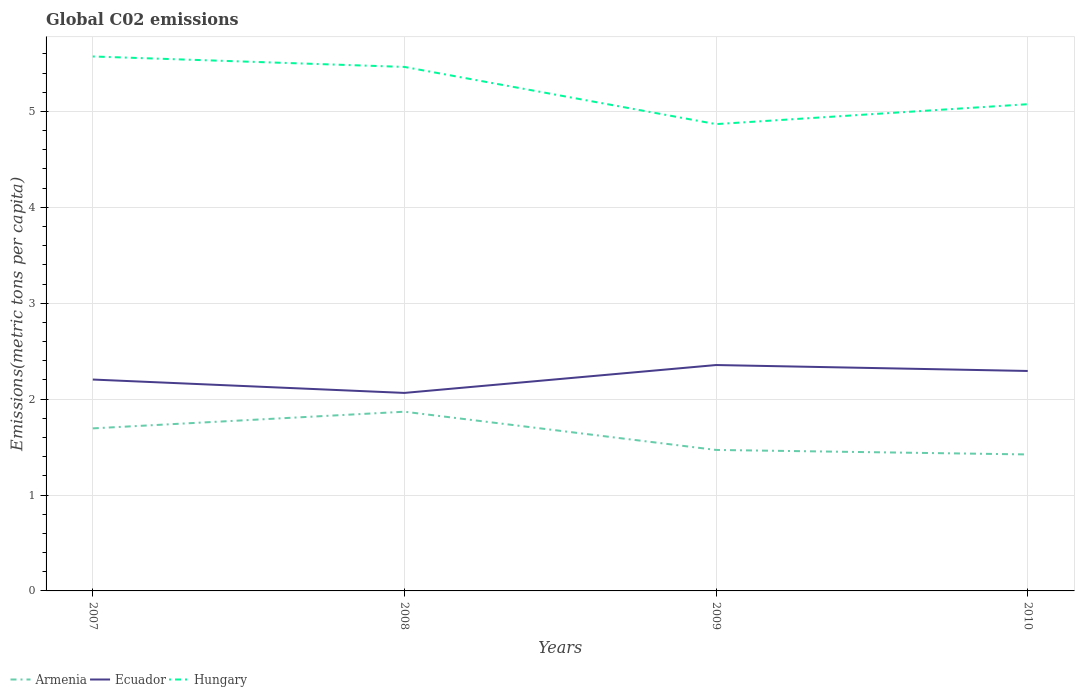Does the line corresponding to Ecuador intersect with the line corresponding to Armenia?
Offer a very short reply. No. Across all years, what is the maximum amount of CO2 emitted in in Hungary?
Give a very brief answer. 4.87. In which year was the amount of CO2 emitted in in Ecuador maximum?
Provide a succinct answer. 2008. What is the total amount of CO2 emitted in in Armenia in the graph?
Make the answer very short. 0.45. What is the difference between the highest and the second highest amount of CO2 emitted in in Hungary?
Offer a terse response. 0.71. What is the difference between the highest and the lowest amount of CO2 emitted in in Hungary?
Your answer should be compact. 2. How many lines are there?
Provide a succinct answer. 3. How many years are there in the graph?
Provide a short and direct response. 4. Does the graph contain any zero values?
Keep it short and to the point. No. Does the graph contain grids?
Keep it short and to the point. Yes. How many legend labels are there?
Give a very brief answer. 3. How are the legend labels stacked?
Make the answer very short. Horizontal. What is the title of the graph?
Offer a terse response. Global C02 emissions. What is the label or title of the X-axis?
Your response must be concise. Years. What is the label or title of the Y-axis?
Your answer should be compact. Emissions(metric tons per capita). What is the Emissions(metric tons per capita) of Armenia in 2007?
Your answer should be compact. 1.69. What is the Emissions(metric tons per capita) of Ecuador in 2007?
Provide a succinct answer. 2.2. What is the Emissions(metric tons per capita) of Hungary in 2007?
Your response must be concise. 5.57. What is the Emissions(metric tons per capita) of Armenia in 2008?
Ensure brevity in your answer.  1.87. What is the Emissions(metric tons per capita) in Ecuador in 2008?
Offer a terse response. 2.06. What is the Emissions(metric tons per capita) of Hungary in 2008?
Make the answer very short. 5.46. What is the Emissions(metric tons per capita) of Armenia in 2009?
Your response must be concise. 1.47. What is the Emissions(metric tons per capita) in Ecuador in 2009?
Make the answer very short. 2.36. What is the Emissions(metric tons per capita) of Hungary in 2009?
Provide a succinct answer. 4.87. What is the Emissions(metric tons per capita) in Armenia in 2010?
Make the answer very short. 1.42. What is the Emissions(metric tons per capita) in Ecuador in 2010?
Provide a short and direct response. 2.29. What is the Emissions(metric tons per capita) of Hungary in 2010?
Give a very brief answer. 5.07. Across all years, what is the maximum Emissions(metric tons per capita) in Armenia?
Provide a succinct answer. 1.87. Across all years, what is the maximum Emissions(metric tons per capita) in Ecuador?
Give a very brief answer. 2.36. Across all years, what is the maximum Emissions(metric tons per capita) of Hungary?
Your answer should be very brief. 5.57. Across all years, what is the minimum Emissions(metric tons per capita) of Armenia?
Offer a very short reply. 1.42. Across all years, what is the minimum Emissions(metric tons per capita) in Ecuador?
Ensure brevity in your answer.  2.06. Across all years, what is the minimum Emissions(metric tons per capita) of Hungary?
Your answer should be very brief. 4.87. What is the total Emissions(metric tons per capita) in Armenia in the graph?
Your response must be concise. 6.46. What is the total Emissions(metric tons per capita) of Ecuador in the graph?
Your answer should be compact. 8.92. What is the total Emissions(metric tons per capita) in Hungary in the graph?
Offer a very short reply. 20.98. What is the difference between the Emissions(metric tons per capita) in Armenia in 2007 and that in 2008?
Offer a terse response. -0.17. What is the difference between the Emissions(metric tons per capita) in Ecuador in 2007 and that in 2008?
Your answer should be compact. 0.14. What is the difference between the Emissions(metric tons per capita) of Hungary in 2007 and that in 2008?
Offer a very short reply. 0.11. What is the difference between the Emissions(metric tons per capita) in Armenia in 2007 and that in 2009?
Keep it short and to the point. 0.22. What is the difference between the Emissions(metric tons per capita) of Ecuador in 2007 and that in 2009?
Offer a very short reply. -0.15. What is the difference between the Emissions(metric tons per capita) of Hungary in 2007 and that in 2009?
Your answer should be compact. 0.71. What is the difference between the Emissions(metric tons per capita) in Armenia in 2007 and that in 2010?
Your answer should be compact. 0.27. What is the difference between the Emissions(metric tons per capita) in Ecuador in 2007 and that in 2010?
Keep it short and to the point. -0.09. What is the difference between the Emissions(metric tons per capita) of Hungary in 2007 and that in 2010?
Provide a succinct answer. 0.5. What is the difference between the Emissions(metric tons per capita) of Armenia in 2008 and that in 2009?
Offer a terse response. 0.4. What is the difference between the Emissions(metric tons per capita) in Ecuador in 2008 and that in 2009?
Ensure brevity in your answer.  -0.29. What is the difference between the Emissions(metric tons per capita) of Hungary in 2008 and that in 2009?
Keep it short and to the point. 0.6. What is the difference between the Emissions(metric tons per capita) of Armenia in 2008 and that in 2010?
Ensure brevity in your answer.  0.45. What is the difference between the Emissions(metric tons per capita) of Ecuador in 2008 and that in 2010?
Your response must be concise. -0.23. What is the difference between the Emissions(metric tons per capita) of Hungary in 2008 and that in 2010?
Keep it short and to the point. 0.39. What is the difference between the Emissions(metric tons per capita) in Armenia in 2009 and that in 2010?
Offer a very short reply. 0.05. What is the difference between the Emissions(metric tons per capita) in Ecuador in 2009 and that in 2010?
Provide a short and direct response. 0.06. What is the difference between the Emissions(metric tons per capita) in Hungary in 2009 and that in 2010?
Your response must be concise. -0.21. What is the difference between the Emissions(metric tons per capita) in Armenia in 2007 and the Emissions(metric tons per capita) in Ecuador in 2008?
Your answer should be very brief. -0.37. What is the difference between the Emissions(metric tons per capita) in Armenia in 2007 and the Emissions(metric tons per capita) in Hungary in 2008?
Your answer should be compact. -3.77. What is the difference between the Emissions(metric tons per capita) of Ecuador in 2007 and the Emissions(metric tons per capita) of Hungary in 2008?
Your response must be concise. -3.26. What is the difference between the Emissions(metric tons per capita) in Armenia in 2007 and the Emissions(metric tons per capita) in Ecuador in 2009?
Your answer should be compact. -0.66. What is the difference between the Emissions(metric tons per capita) of Armenia in 2007 and the Emissions(metric tons per capita) of Hungary in 2009?
Offer a terse response. -3.17. What is the difference between the Emissions(metric tons per capita) of Ecuador in 2007 and the Emissions(metric tons per capita) of Hungary in 2009?
Ensure brevity in your answer.  -2.66. What is the difference between the Emissions(metric tons per capita) of Armenia in 2007 and the Emissions(metric tons per capita) of Ecuador in 2010?
Make the answer very short. -0.6. What is the difference between the Emissions(metric tons per capita) in Armenia in 2007 and the Emissions(metric tons per capita) in Hungary in 2010?
Ensure brevity in your answer.  -3.38. What is the difference between the Emissions(metric tons per capita) in Ecuador in 2007 and the Emissions(metric tons per capita) in Hungary in 2010?
Make the answer very short. -2.87. What is the difference between the Emissions(metric tons per capita) of Armenia in 2008 and the Emissions(metric tons per capita) of Ecuador in 2009?
Give a very brief answer. -0.49. What is the difference between the Emissions(metric tons per capita) in Armenia in 2008 and the Emissions(metric tons per capita) in Hungary in 2009?
Your response must be concise. -3. What is the difference between the Emissions(metric tons per capita) of Ecuador in 2008 and the Emissions(metric tons per capita) of Hungary in 2009?
Make the answer very short. -2.8. What is the difference between the Emissions(metric tons per capita) in Armenia in 2008 and the Emissions(metric tons per capita) in Ecuador in 2010?
Your answer should be very brief. -0.42. What is the difference between the Emissions(metric tons per capita) in Armenia in 2008 and the Emissions(metric tons per capita) in Hungary in 2010?
Keep it short and to the point. -3.21. What is the difference between the Emissions(metric tons per capita) of Ecuador in 2008 and the Emissions(metric tons per capita) of Hungary in 2010?
Ensure brevity in your answer.  -3.01. What is the difference between the Emissions(metric tons per capita) in Armenia in 2009 and the Emissions(metric tons per capita) in Ecuador in 2010?
Give a very brief answer. -0.82. What is the difference between the Emissions(metric tons per capita) of Armenia in 2009 and the Emissions(metric tons per capita) of Hungary in 2010?
Give a very brief answer. -3.6. What is the difference between the Emissions(metric tons per capita) in Ecuador in 2009 and the Emissions(metric tons per capita) in Hungary in 2010?
Provide a succinct answer. -2.72. What is the average Emissions(metric tons per capita) in Armenia per year?
Your response must be concise. 1.61. What is the average Emissions(metric tons per capita) in Ecuador per year?
Make the answer very short. 2.23. What is the average Emissions(metric tons per capita) of Hungary per year?
Offer a terse response. 5.24. In the year 2007, what is the difference between the Emissions(metric tons per capita) of Armenia and Emissions(metric tons per capita) of Ecuador?
Give a very brief answer. -0.51. In the year 2007, what is the difference between the Emissions(metric tons per capita) of Armenia and Emissions(metric tons per capita) of Hungary?
Provide a succinct answer. -3.88. In the year 2007, what is the difference between the Emissions(metric tons per capita) in Ecuador and Emissions(metric tons per capita) in Hungary?
Give a very brief answer. -3.37. In the year 2008, what is the difference between the Emissions(metric tons per capita) of Armenia and Emissions(metric tons per capita) of Ecuador?
Your answer should be very brief. -0.2. In the year 2008, what is the difference between the Emissions(metric tons per capita) of Armenia and Emissions(metric tons per capita) of Hungary?
Your answer should be very brief. -3.59. In the year 2008, what is the difference between the Emissions(metric tons per capita) in Ecuador and Emissions(metric tons per capita) in Hungary?
Ensure brevity in your answer.  -3.4. In the year 2009, what is the difference between the Emissions(metric tons per capita) in Armenia and Emissions(metric tons per capita) in Ecuador?
Your answer should be very brief. -0.89. In the year 2009, what is the difference between the Emissions(metric tons per capita) in Armenia and Emissions(metric tons per capita) in Hungary?
Your answer should be compact. -3.4. In the year 2009, what is the difference between the Emissions(metric tons per capita) of Ecuador and Emissions(metric tons per capita) of Hungary?
Your answer should be compact. -2.51. In the year 2010, what is the difference between the Emissions(metric tons per capita) in Armenia and Emissions(metric tons per capita) in Ecuador?
Offer a very short reply. -0.87. In the year 2010, what is the difference between the Emissions(metric tons per capita) of Armenia and Emissions(metric tons per capita) of Hungary?
Offer a terse response. -3.65. In the year 2010, what is the difference between the Emissions(metric tons per capita) in Ecuador and Emissions(metric tons per capita) in Hungary?
Offer a terse response. -2.78. What is the ratio of the Emissions(metric tons per capita) of Armenia in 2007 to that in 2008?
Provide a succinct answer. 0.91. What is the ratio of the Emissions(metric tons per capita) of Ecuador in 2007 to that in 2008?
Make the answer very short. 1.07. What is the ratio of the Emissions(metric tons per capita) of Hungary in 2007 to that in 2008?
Give a very brief answer. 1.02. What is the ratio of the Emissions(metric tons per capita) of Armenia in 2007 to that in 2009?
Provide a succinct answer. 1.15. What is the ratio of the Emissions(metric tons per capita) in Ecuador in 2007 to that in 2009?
Provide a succinct answer. 0.94. What is the ratio of the Emissions(metric tons per capita) of Hungary in 2007 to that in 2009?
Offer a very short reply. 1.14. What is the ratio of the Emissions(metric tons per capita) of Armenia in 2007 to that in 2010?
Provide a short and direct response. 1.19. What is the ratio of the Emissions(metric tons per capita) in Ecuador in 2007 to that in 2010?
Provide a succinct answer. 0.96. What is the ratio of the Emissions(metric tons per capita) of Hungary in 2007 to that in 2010?
Offer a terse response. 1.1. What is the ratio of the Emissions(metric tons per capita) of Armenia in 2008 to that in 2009?
Keep it short and to the point. 1.27. What is the ratio of the Emissions(metric tons per capita) in Ecuador in 2008 to that in 2009?
Provide a succinct answer. 0.88. What is the ratio of the Emissions(metric tons per capita) of Hungary in 2008 to that in 2009?
Your answer should be compact. 1.12. What is the ratio of the Emissions(metric tons per capita) of Armenia in 2008 to that in 2010?
Provide a short and direct response. 1.31. What is the ratio of the Emissions(metric tons per capita) in Ecuador in 2008 to that in 2010?
Your response must be concise. 0.9. What is the ratio of the Emissions(metric tons per capita) of Hungary in 2008 to that in 2010?
Make the answer very short. 1.08. What is the ratio of the Emissions(metric tons per capita) of Armenia in 2009 to that in 2010?
Your response must be concise. 1.03. What is the ratio of the Emissions(metric tons per capita) of Hungary in 2009 to that in 2010?
Offer a very short reply. 0.96. What is the difference between the highest and the second highest Emissions(metric tons per capita) of Armenia?
Give a very brief answer. 0.17. What is the difference between the highest and the second highest Emissions(metric tons per capita) of Ecuador?
Keep it short and to the point. 0.06. What is the difference between the highest and the second highest Emissions(metric tons per capita) of Hungary?
Provide a short and direct response. 0.11. What is the difference between the highest and the lowest Emissions(metric tons per capita) in Armenia?
Your response must be concise. 0.45. What is the difference between the highest and the lowest Emissions(metric tons per capita) of Ecuador?
Your answer should be compact. 0.29. What is the difference between the highest and the lowest Emissions(metric tons per capita) in Hungary?
Make the answer very short. 0.71. 